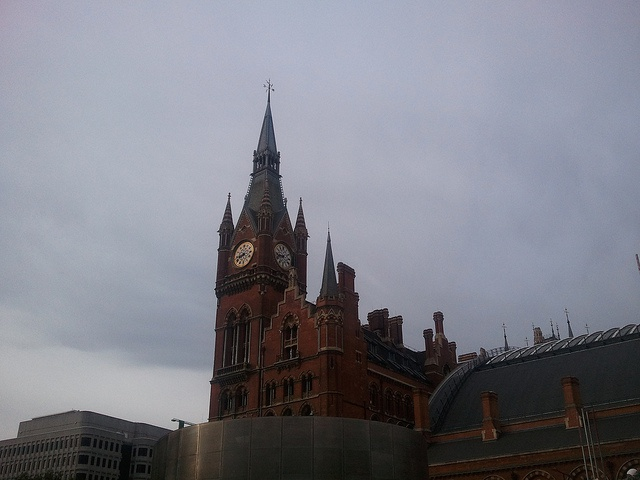Describe the objects in this image and their specific colors. I can see clock in darkgray, gray, tan, and black tones and clock in darkgray, black, and gray tones in this image. 